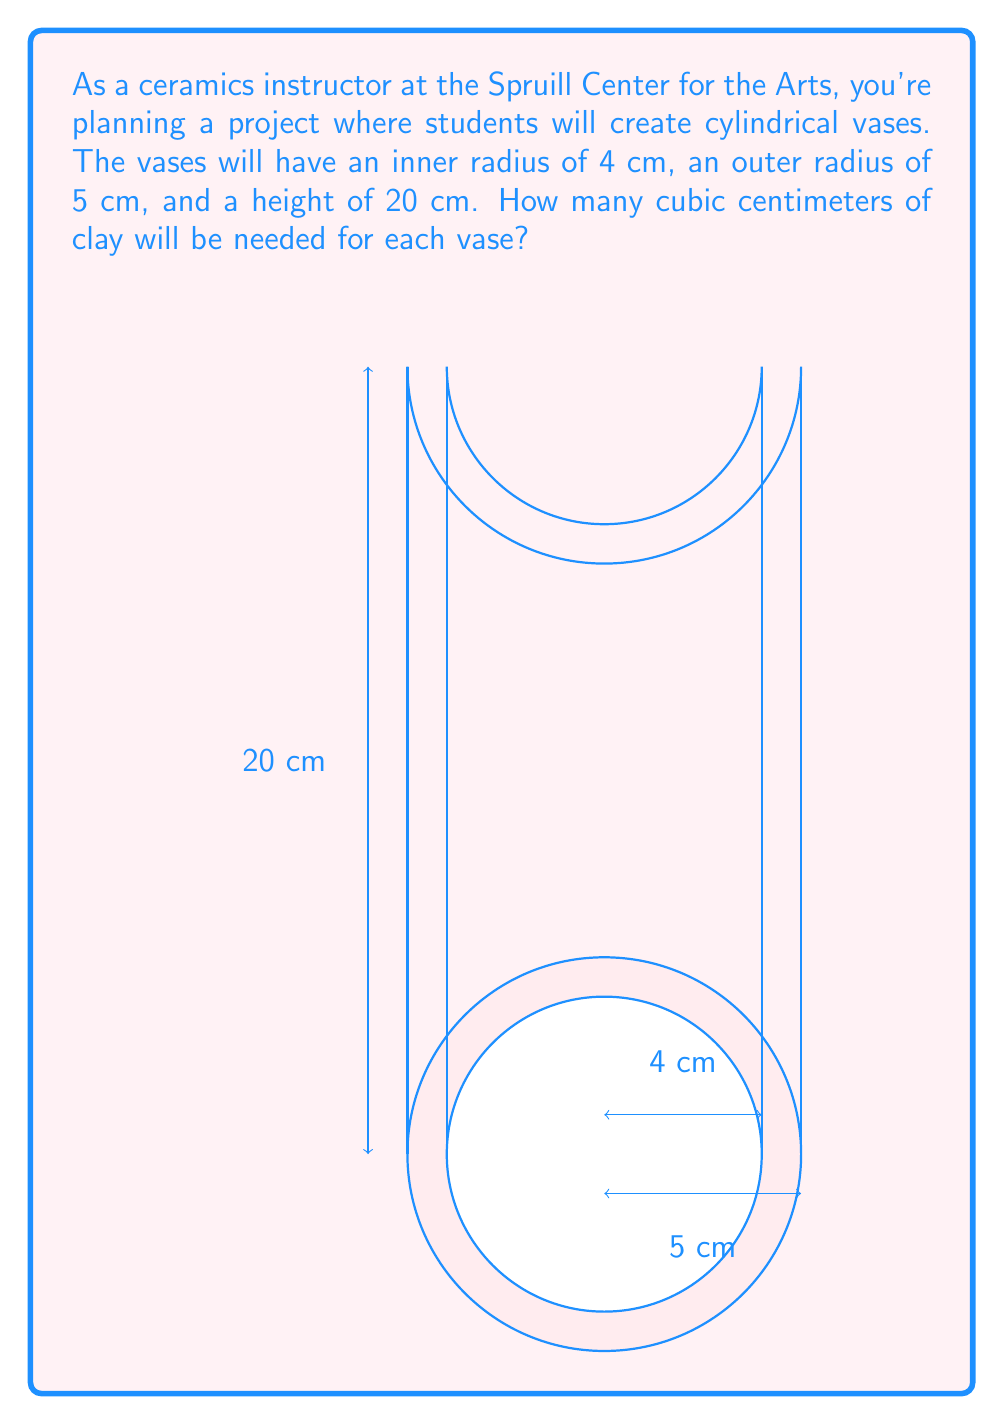Solve this math problem. To solve this problem, we need to follow these steps:

1) The volume of clay needed is the difference between the volume of the outer cylinder and the volume of the inner cylinder (which will be hollow).

2) The formula for the volume of a cylinder is $V = \pi r^2 h$, where $r$ is the radius and $h$ is the height.

3) For the outer cylinder:
   $V_{outer} = \pi (5\text{ cm})^2 (20\text{ cm})$
   $V_{outer} = 500\pi\text{ cm}^3$

4) For the inner cylinder:
   $V_{inner} = \pi (4\text{ cm})^2 (20\text{ cm})$
   $V_{inner} = 320\pi\text{ cm}^3$

5) The volume of clay needed is:
   $V_{clay} = V_{outer} - V_{inner}$
   $V_{clay} = 500\pi\text{ cm}^3 - 320\pi\text{ cm}^3$
   $V_{clay} = 180\pi\text{ cm}^3$

6) Calculating the final value:
   $V_{clay} = 180 \times 3.14159... \approx 565.49\text{ cm}^3$

Therefore, approximately 565.49 cubic centimeters of clay will be needed for each vase.
Answer: $565.49\text{ cm}^3$ 